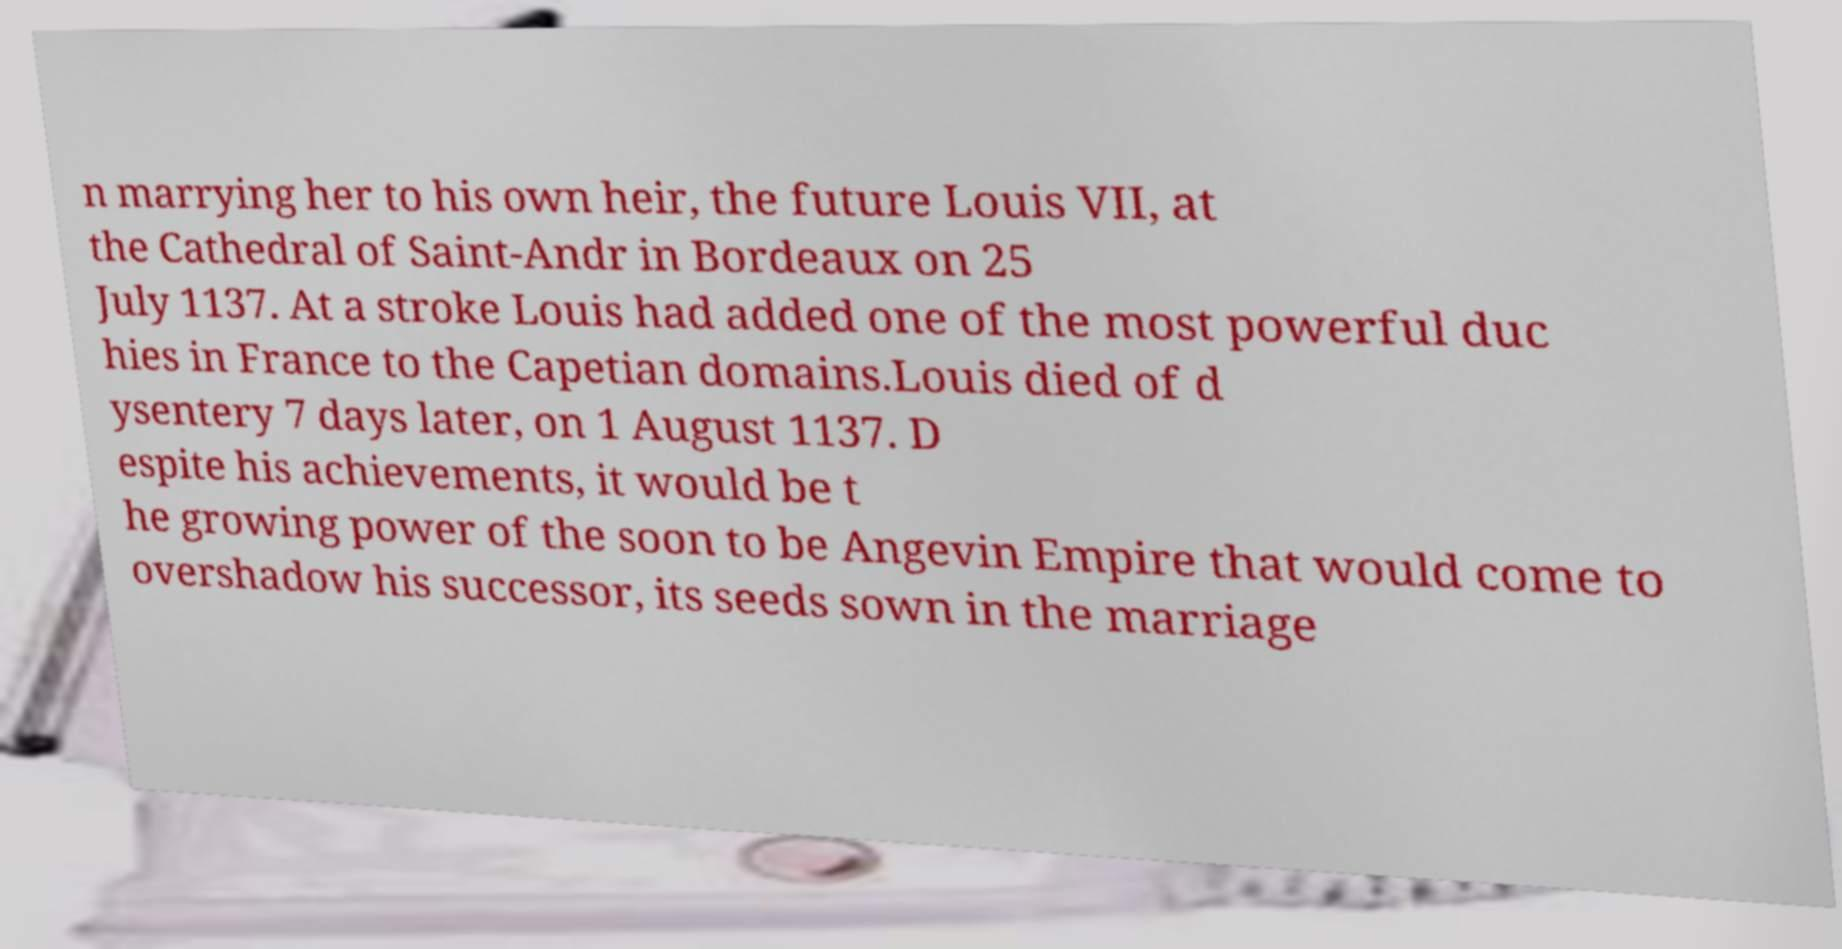There's text embedded in this image that I need extracted. Can you transcribe it verbatim? n marrying her to his own heir, the future Louis VII, at the Cathedral of Saint-Andr in Bordeaux on 25 July 1137. At a stroke Louis had added one of the most powerful duc hies in France to the Capetian domains.Louis died of d ysentery 7 days later, on 1 August 1137. D espite his achievements, it would be t he growing power of the soon to be Angevin Empire that would come to overshadow his successor, its seeds sown in the marriage 